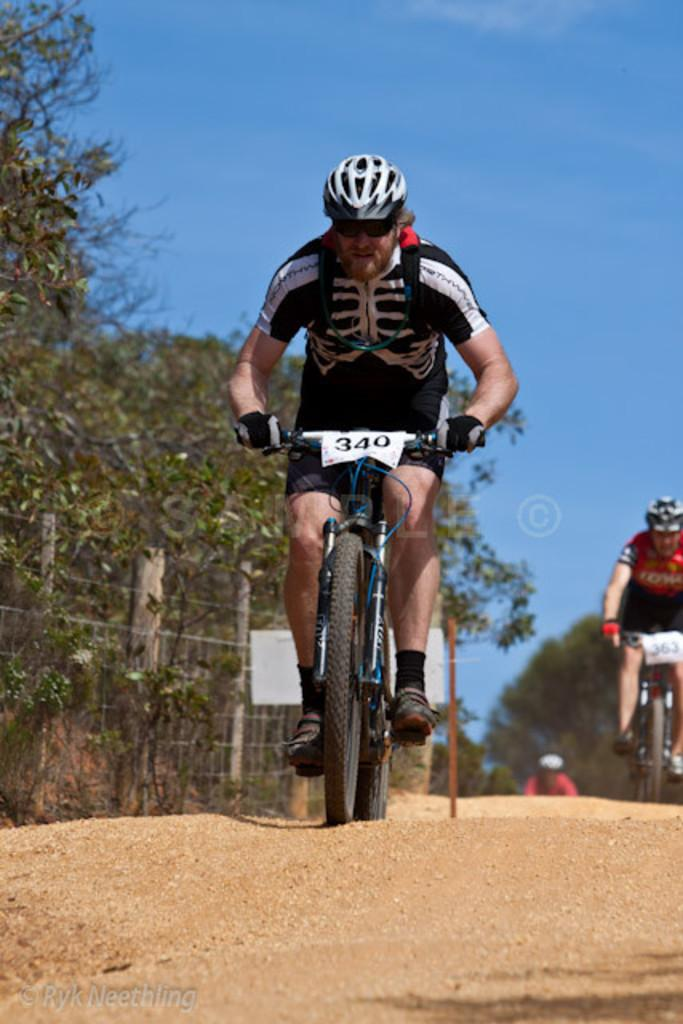What are the two people in the image doing? The two people in the image are bicycling. Where are the people bicycling? The people are on a road. What can be seen on the left side of the image? There are trees on the left side of the image. What is visible in the background of the image? There is a sky visible in the background of the image. What type of spoon is being used to wash the morning dew off the trees in the image? There is no spoon or morning dew present in the image. The image features two people bicycling on a road, with trees on the left side and a sky visible in the background. 